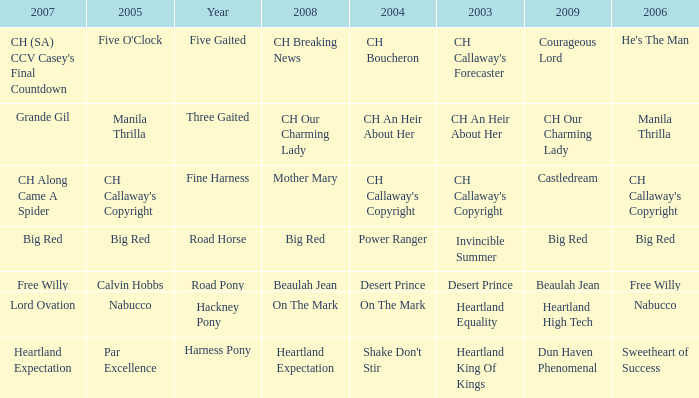What is the 2008 for the 2009 ch our charming lady? CH Our Charming Lady. 